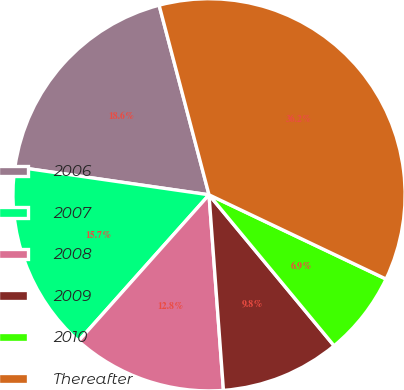Convert chart to OTSL. <chart><loc_0><loc_0><loc_500><loc_500><pie_chart><fcel>2006<fcel>2007<fcel>2008<fcel>2009<fcel>2010<fcel>Thereafter<nl><fcel>18.62%<fcel>15.69%<fcel>12.77%<fcel>9.84%<fcel>6.92%<fcel>36.17%<nl></chart> 